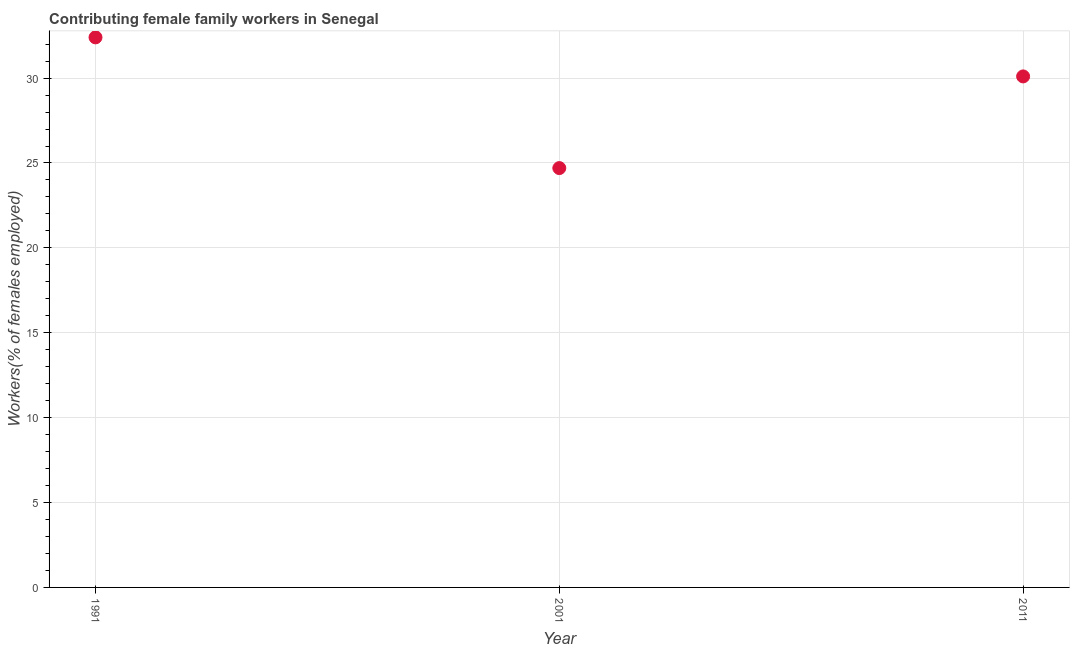What is the contributing female family workers in 2001?
Provide a succinct answer. 24.7. Across all years, what is the maximum contributing female family workers?
Ensure brevity in your answer.  32.4. Across all years, what is the minimum contributing female family workers?
Provide a short and direct response. 24.7. In which year was the contributing female family workers maximum?
Provide a short and direct response. 1991. What is the sum of the contributing female family workers?
Make the answer very short. 87.2. What is the difference between the contributing female family workers in 1991 and 2011?
Provide a short and direct response. 2.3. What is the average contributing female family workers per year?
Your answer should be very brief. 29.07. What is the median contributing female family workers?
Your answer should be very brief. 30.1. In how many years, is the contributing female family workers greater than 28 %?
Offer a very short reply. 2. What is the ratio of the contributing female family workers in 2001 to that in 2011?
Give a very brief answer. 0.82. What is the difference between the highest and the second highest contributing female family workers?
Your answer should be compact. 2.3. Is the sum of the contributing female family workers in 1991 and 2011 greater than the maximum contributing female family workers across all years?
Your answer should be very brief. Yes. What is the difference between the highest and the lowest contributing female family workers?
Provide a succinct answer. 7.7. Does the contributing female family workers monotonically increase over the years?
Provide a short and direct response. No. What is the difference between two consecutive major ticks on the Y-axis?
Provide a succinct answer. 5. Does the graph contain any zero values?
Your answer should be compact. No. Does the graph contain grids?
Keep it short and to the point. Yes. What is the title of the graph?
Provide a short and direct response. Contributing female family workers in Senegal. What is the label or title of the X-axis?
Ensure brevity in your answer.  Year. What is the label or title of the Y-axis?
Your answer should be compact. Workers(% of females employed). What is the Workers(% of females employed) in 1991?
Make the answer very short. 32.4. What is the Workers(% of females employed) in 2001?
Your answer should be compact. 24.7. What is the Workers(% of females employed) in 2011?
Offer a very short reply. 30.1. What is the difference between the Workers(% of females employed) in 2001 and 2011?
Ensure brevity in your answer.  -5.4. What is the ratio of the Workers(% of females employed) in 1991 to that in 2001?
Your response must be concise. 1.31. What is the ratio of the Workers(% of females employed) in 1991 to that in 2011?
Keep it short and to the point. 1.08. What is the ratio of the Workers(% of females employed) in 2001 to that in 2011?
Keep it short and to the point. 0.82. 